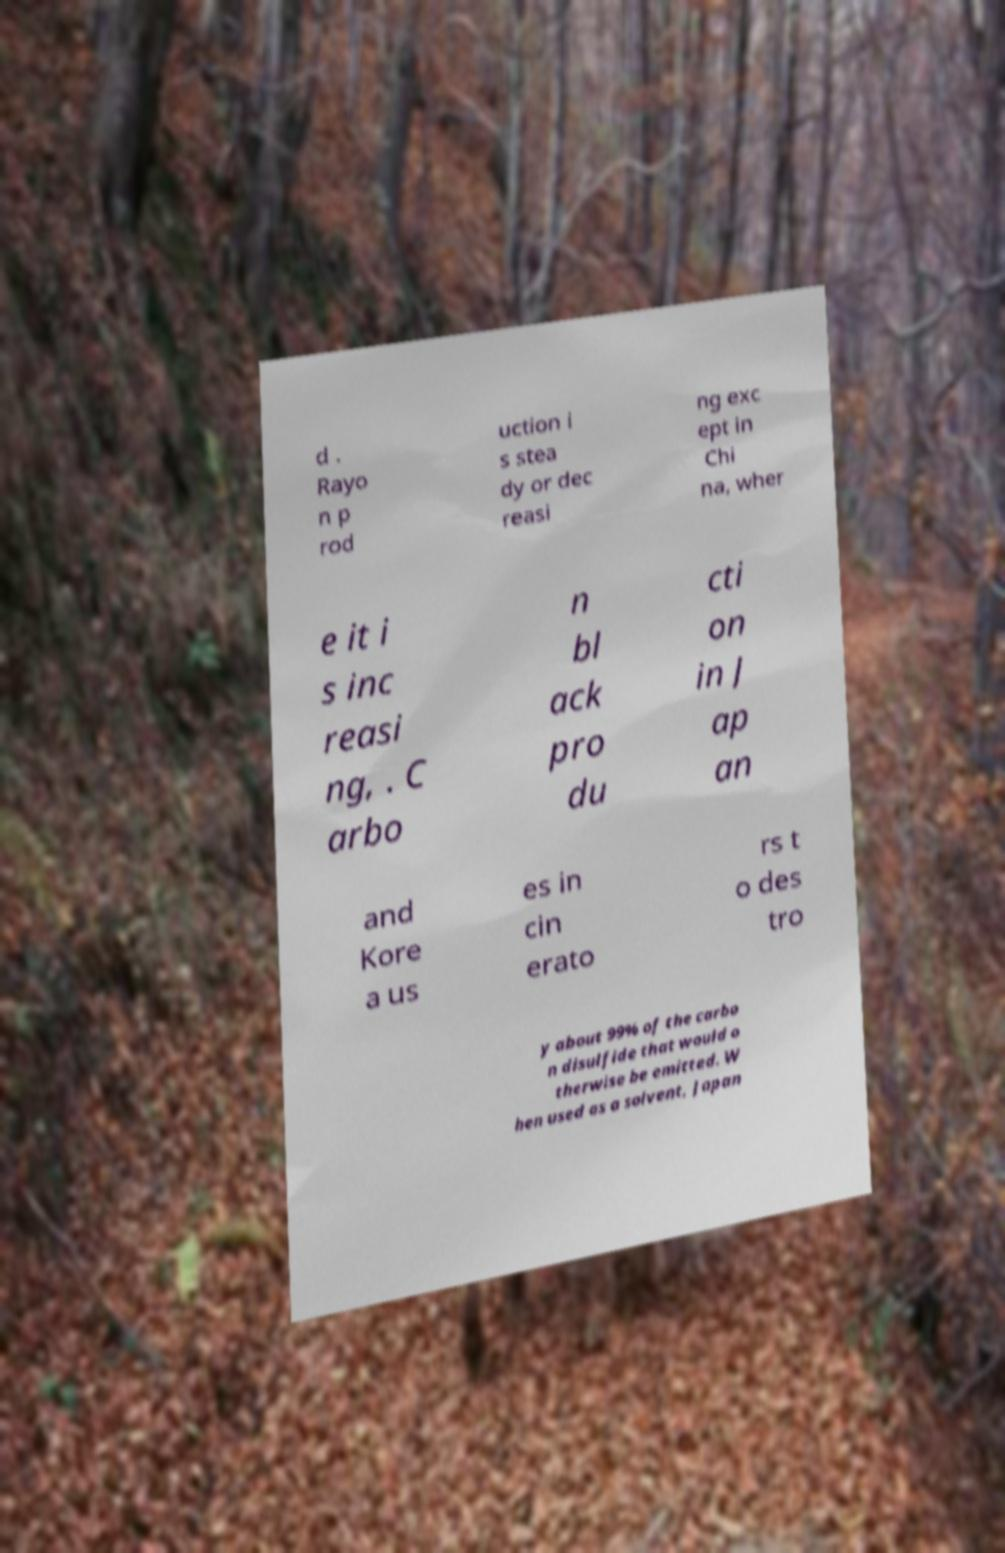For documentation purposes, I need the text within this image transcribed. Could you provide that? d . Rayo n p rod uction i s stea dy or dec reasi ng exc ept in Chi na, wher e it i s inc reasi ng, . C arbo n bl ack pro du cti on in J ap an and Kore a us es in cin erato rs t o des tro y about 99% of the carbo n disulfide that would o therwise be emitted. W hen used as a solvent, Japan 